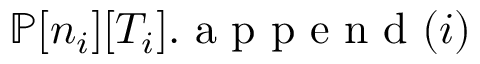<formula> <loc_0><loc_0><loc_500><loc_500>{ \mathbb { P } } [ n _ { i } ] [ T _ { i } ] . a p p e n d ( i )</formula> 